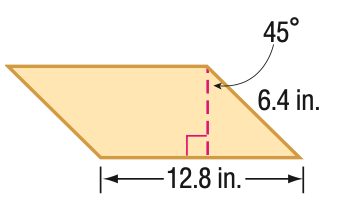Answer the mathemtical geometry problem and directly provide the correct option letter.
Question: Find the area of the parallelogram. Round to the nearest tenth if necessary.
Choices: A: 41.0 B: 57.9 C: 70.9 D: 81.9 B 